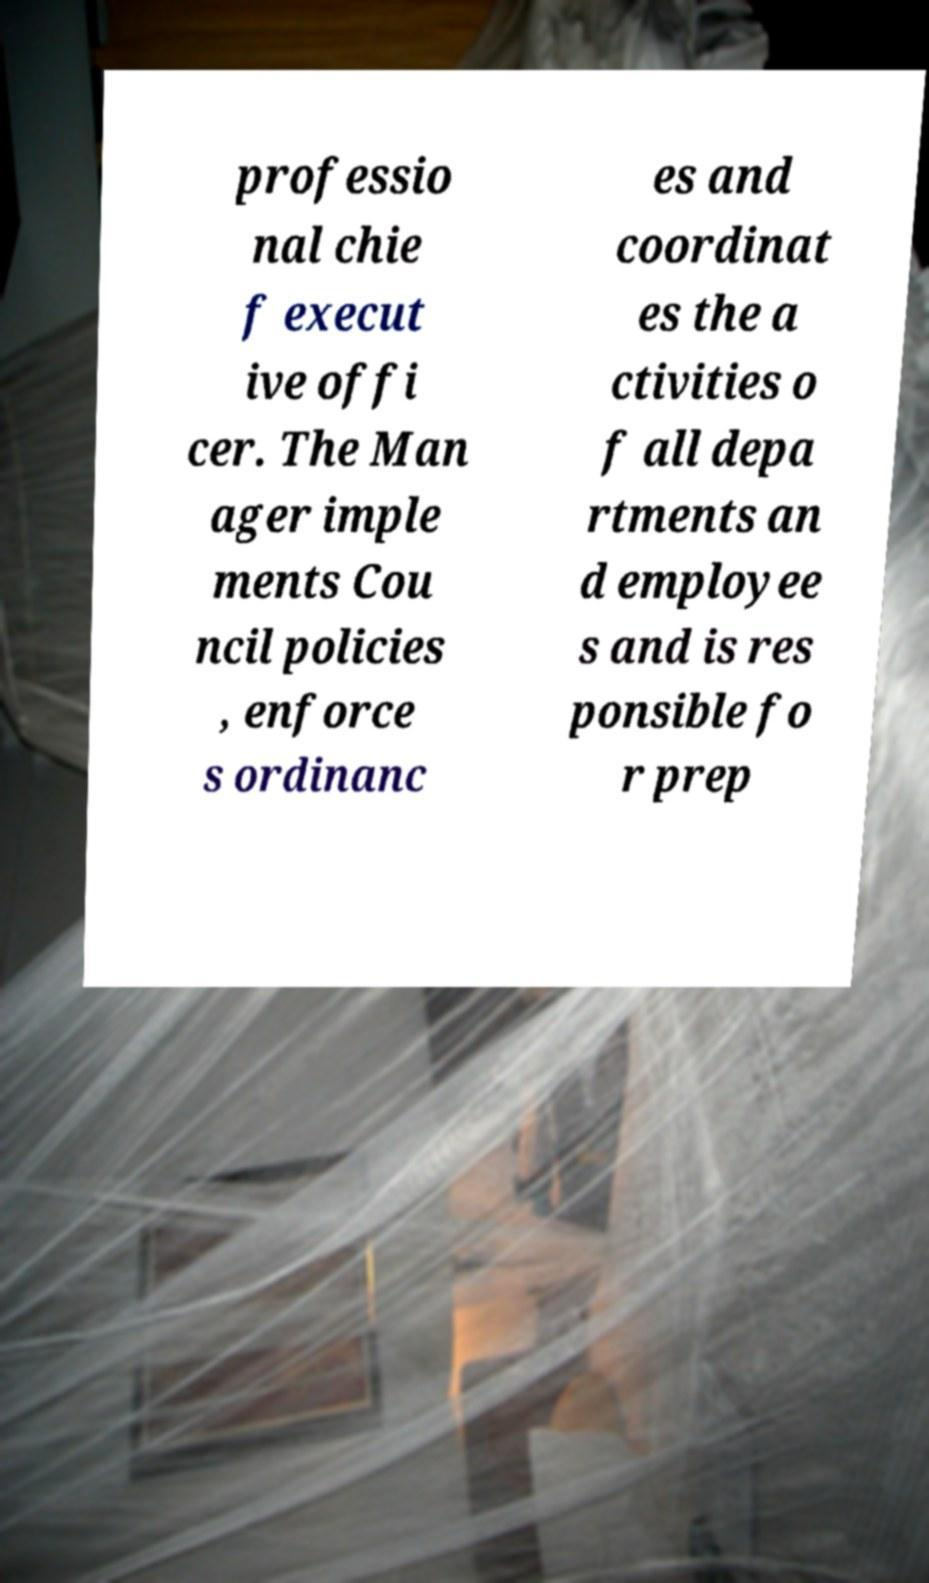Please read and relay the text visible in this image. What does it say? professio nal chie f execut ive offi cer. The Man ager imple ments Cou ncil policies , enforce s ordinanc es and coordinat es the a ctivities o f all depa rtments an d employee s and is res ponsible fo r prep 